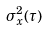Convert formula to latex. <formula><loc_0><loc_0><loc_500><loc_500>\sigma _ { x } ^ { 2 } ( \tau )</formula> 